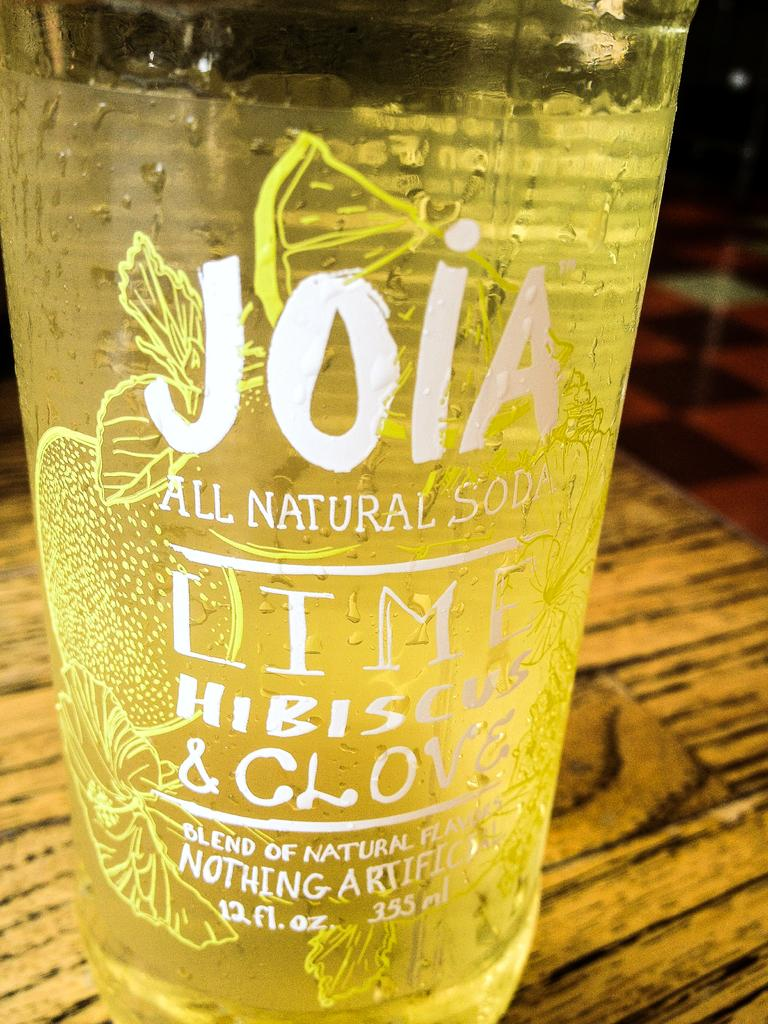<image>
Provide a brief description of the given image. An ice cold glass of Lime Hibiscus All Natural Soda has been poured into a glass 